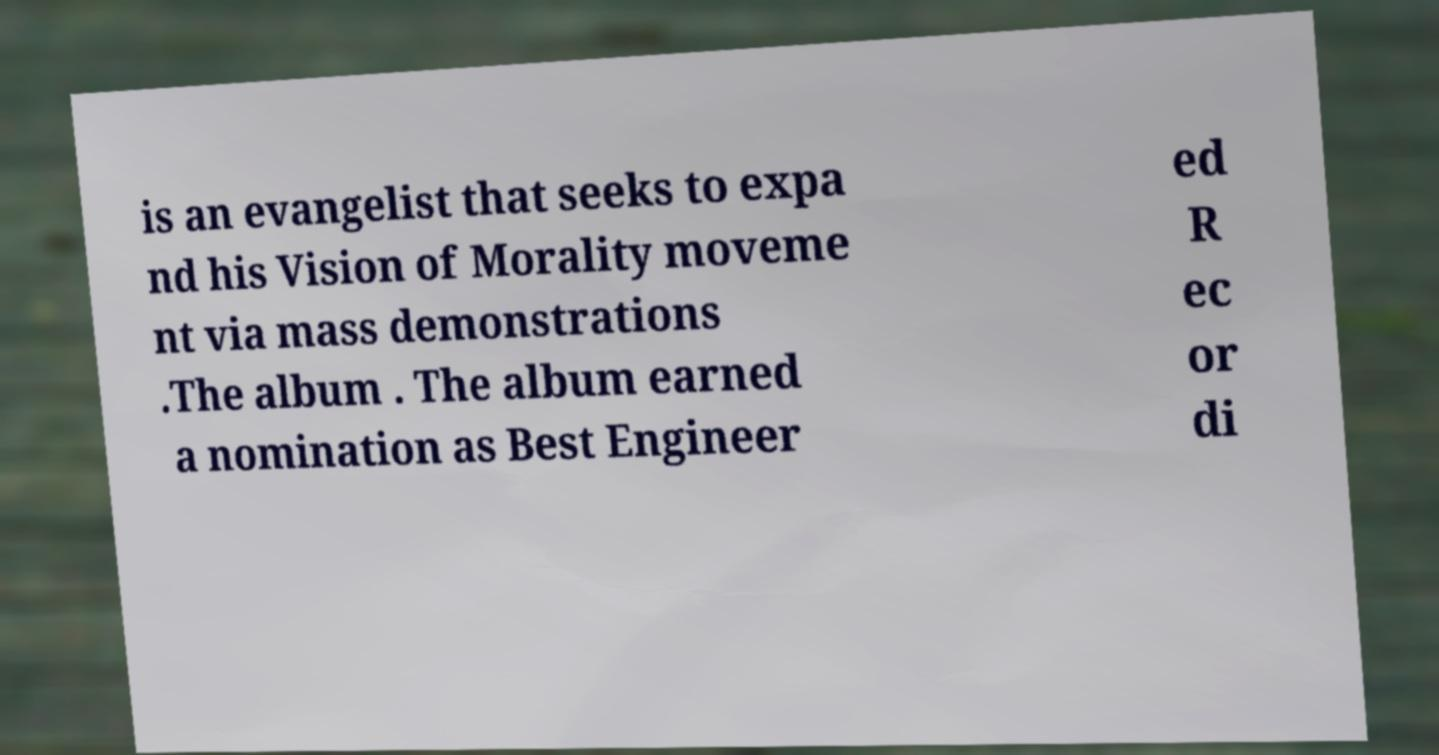For documentation purposes, I need the text within this image transcribed. Could you provide that? is an evangelist that seeks to expa nd his Vision of Morality moveme nt via mass demonstrations .The album . The album earned a nomination as Best Engineer ed R ec or di 